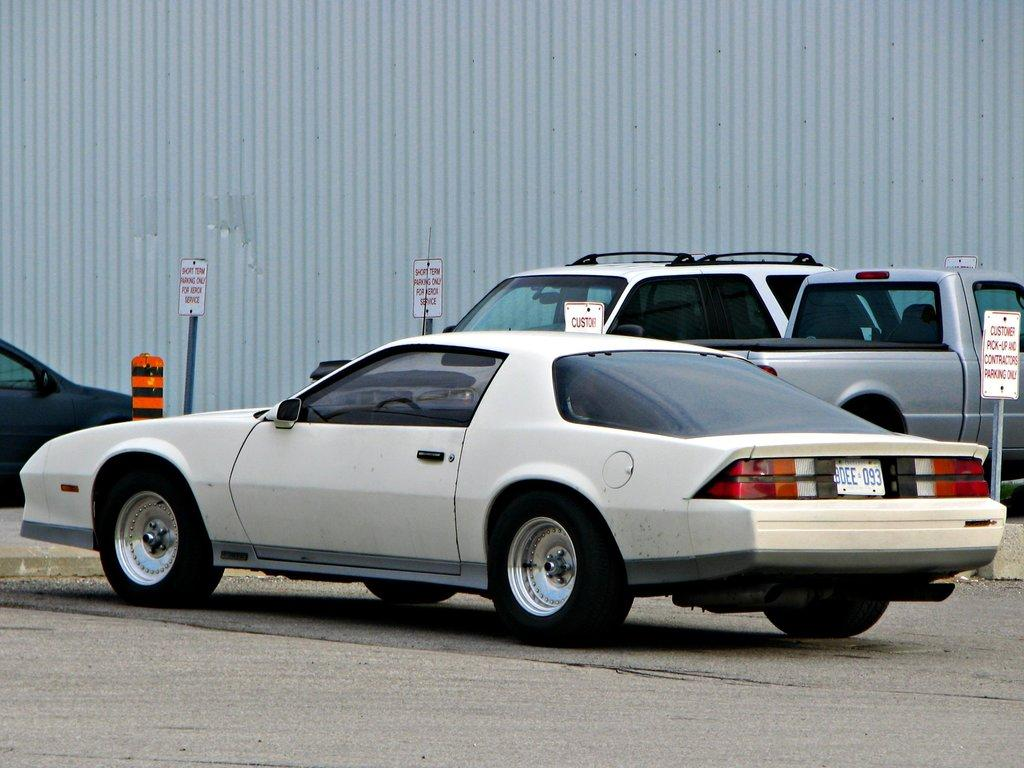What is happening on the road in the image? There are vehicles on the road in the image. What type of signs are present in the image? There are boards on poles in the image. Can you describe the object in the image? There is an object in the image, but its specific details are not mentioned in the provided facts. What can be seen in the background of the image? There is a metal sheet visible in the background of the image. How many bombs are visible in the image? There are no bombs present in the image. What type of selection process is being conducted in the image? There is no selection process depicted in the image. 